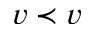<formula> <loc_0><loc_0><loc_500><loc_500>v \prec v</formula> 